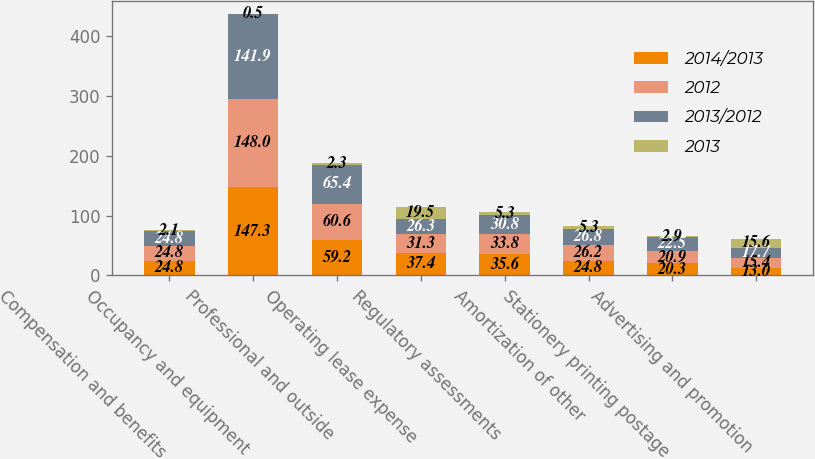<chart> <loc_0><loc_0><loc_500><loc_500><stacked_bar_chart><ecel><fcel>Compensation and benefits<fcel>Occupancy and equipment<fcel>Professional and outside<fcel>Operating lease expense<fcel>Regulatory assessments<fcel>Amortization of other<fcel>Stationery printing postage<fcel>Advertising and promotion<nl><fcel>2014/2013<fcel>24.8<fcel>147.3<fcel>59.2<fcel>37.4<fcel>35.6<fcel>24.8<fcel>20.3<fcel>13<nl><fcel>2012<fcel>24.8<fcel>148<fcel>60.6<fcel>31.3<fcel>33.8<fcel>26.2<fcel>20.9<fcel>15.4<nl><fcel>2013/2012<fcel>24.8<fcel>141.9<fcel>65.4<fcel>26.3<fcel>30.8<fcel>26.8<fcel>22.5<fcel>17.7<nl><fcel>2013<fcel>2.1<fcel>0.5<fcel>2.3<fcel>19.5<fcel>5.3<fcel>5.3<fcel>2.9<fcel>15.6<nl></chart> 